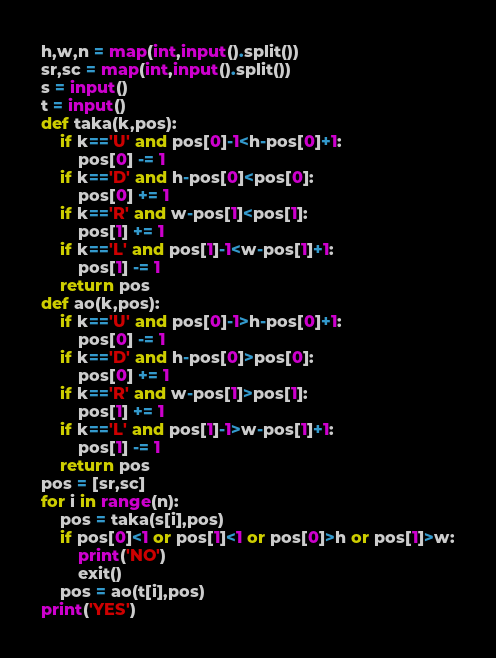Convert code to text. <code><loc_0><loc_0><loc_500><loc_500><_Python_>h,w,n = map(int,input().split())
sr,sc = map(int,input().split())
s = input()
t = input()
def taka(k,pos):
    if k=='U' and pos[0]-1<h-pos[0]+1:
        pos[0] -= 1
    if k=='D' and h-pos[0]<pos[0]:
        pos[0] += 1
    if k=='R' and w-pos[1]<pos[1]:
        pos[1] += 1
    if k=='L' and pos[1]-1<w-pos[1]+1:
        pos[1] -= 1
    return pos
def ao(k,pos):
    if k=='U' and pos[0]-1>h-pos[0]+1:
        pos[0] -= 1
    if k=='D' and h-pos[0]>pos[0]:
        pos[0] += 1
    if k=='R' and w-pos[1]>pos[1]:
        pos[1] += 1
    if k=='L' and pos[1]-1>w-pos[1]+1:
        pos[1] -= 1
    return pos
pos = [sr,sc]
for i in range(n):
    pos = taka(s[i],pos)
    if pos[0]<1 or pos[1]<1 or pos[0]>h or pos[1]>w:
        print('NO')
        exit()
    pos = ao(t[i],pos)
print('YES')</code> 